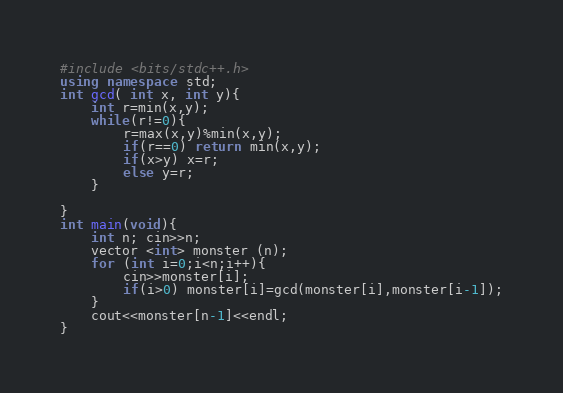Convert code to text. <code><loc_0><loc_0><loc_500><loc_500><_C++_>#include <bits/stdc++.h>
using namespace std;
int gcd( int x, int y){
    int r=min(x,y);
    while(r!=0){
        r=max(x,y)%min(x,y);
        if(r==0) return min(x,y);
        if(x>y) x=r;
        else y=r;
    }
    
}
int main(void){
    int n; cin>>n;
    vector <int> monster (n);
    for (int i=0;i<n;i++){
        cin>>monster[i];
        if(i>0) monster[i]=gcd(monster[i],monster[i-1]);
    }
    cout<<monster[n-1]<<endl;
}
</code> 